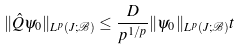Convert formula to latex. <formula><loc_0><loc_0><loc_500><loc_500>\| \hat { Q } \psi _ { 0 } \| _ { L ^ { p } ( J ; \mathcal { B } ) } \leq \frac { D } { p ^ { 1 / p } } \| \psi _ { 0 } \| _ { L ^ { p } ( J ; \mathcal { B } ) } t</formula> 